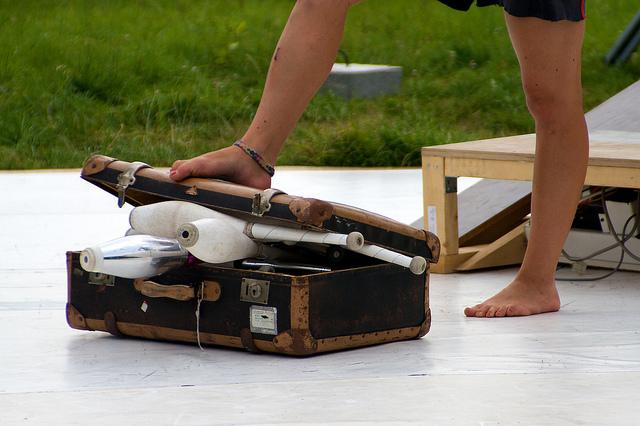What does the person do with these pins?
Answer briefly. Juggle. Does this person wear an ankle bracelet?
Keep it brief. Yes. What do you call this person?
Keep it brief. Juggler. 